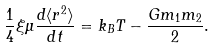Convert formula to latex. <formula><loc_0><loc_0><loc_500><loc_500>\frac { 1 } { 4 } \xi \mu \frac { d \langle r ^ { 2 } \rangle } { d t } = k _ { B } T - \frac { G m _ { 1 } m _ { 2 } } { 2 } .</formula> 